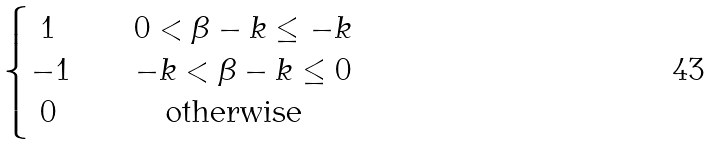Convert formula to latex. <formula><loc_0><loc_0><loc_500><loc_500>\begin{cases} \ 1 & \quad 0 < \beta - k \leq - k \\ - 1 & \quad - k < \beta - k \leq 0 \\ \ 0 & \quad \text {\quad otherwise} \\ \end{cases}</formula> 